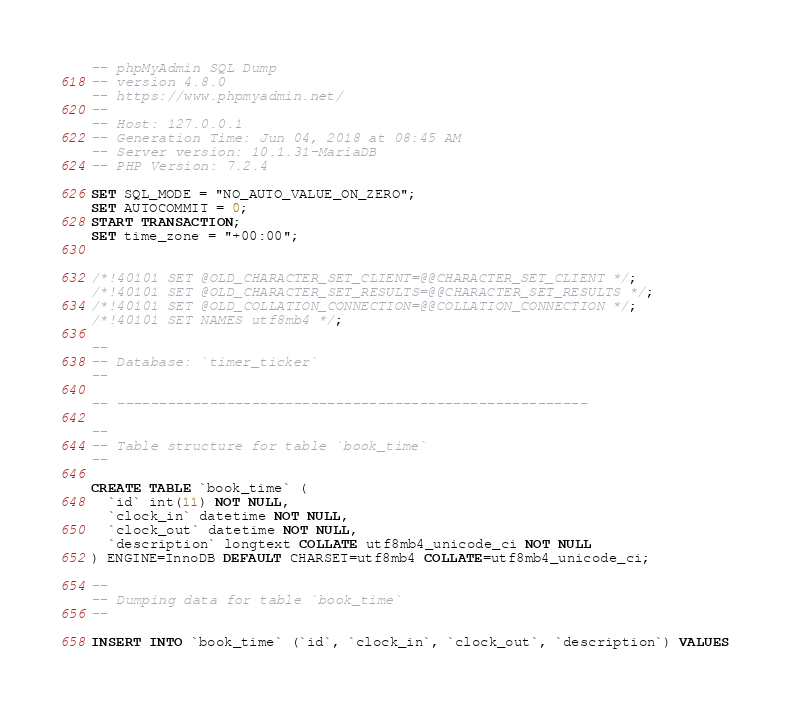<code> <loc_0><loc_0><loc_500><loc_500><_SQL_>-- phpMyAdmin SQL Dump
-- version 4.8.0
-- https://www.phpmyadmin.net/
--
-- Host: 127.0.0.1
-- Generation Time: Jun 04, 2018 at 08:45 AM
-- Server version: 10.1.31-MariaDB
-- PHP Version: 7.2.4

SET SQL_MODE = "NO_AUTO_VALUE_ON_ZERO";
SET AUTOCOMMIT = 0;
START TRANSACTION;
SET time_zone = "+00:00";


/*!40101 SET @OLD_CHARACTER_SET_CLIENT=@@CHARACTER_SET_CLIENT */;
/*!40101 SET @OLD_CHARACTER_SET_RESULTS=@@CHARACTER_SET_RESULTS */;
/*!40101 SET @OLD_COLLATION_CONNECTION=@@COLLATION_CONNECTION */;
/*!40101 SET NAMES utf8mb4 */;

--
-- Database: `timer_ticker`
--

-- --------------------------------------------------------

--
-- Table structure for table `book_time`
--

CREATE TABLE `book_time` (
  `id` int(11) NOT NULL,
  `clock_in` datetime NOT NULL,
  `clock_out` datetime NOT NULL,
  `description` longtext COLLATE utf8mb4_unicode_ci NOT NULL
) ENGINE=InnoDB DEFAULT CHARSET=utf8mb4 COLLATE=utf8mb4_unicode_ci;

--
-- Dumping data for table `book_time`
--

INSERT INTO `book_time` (`id`, `clock_in`, `clock_out`, `description`) VALUES</code> 